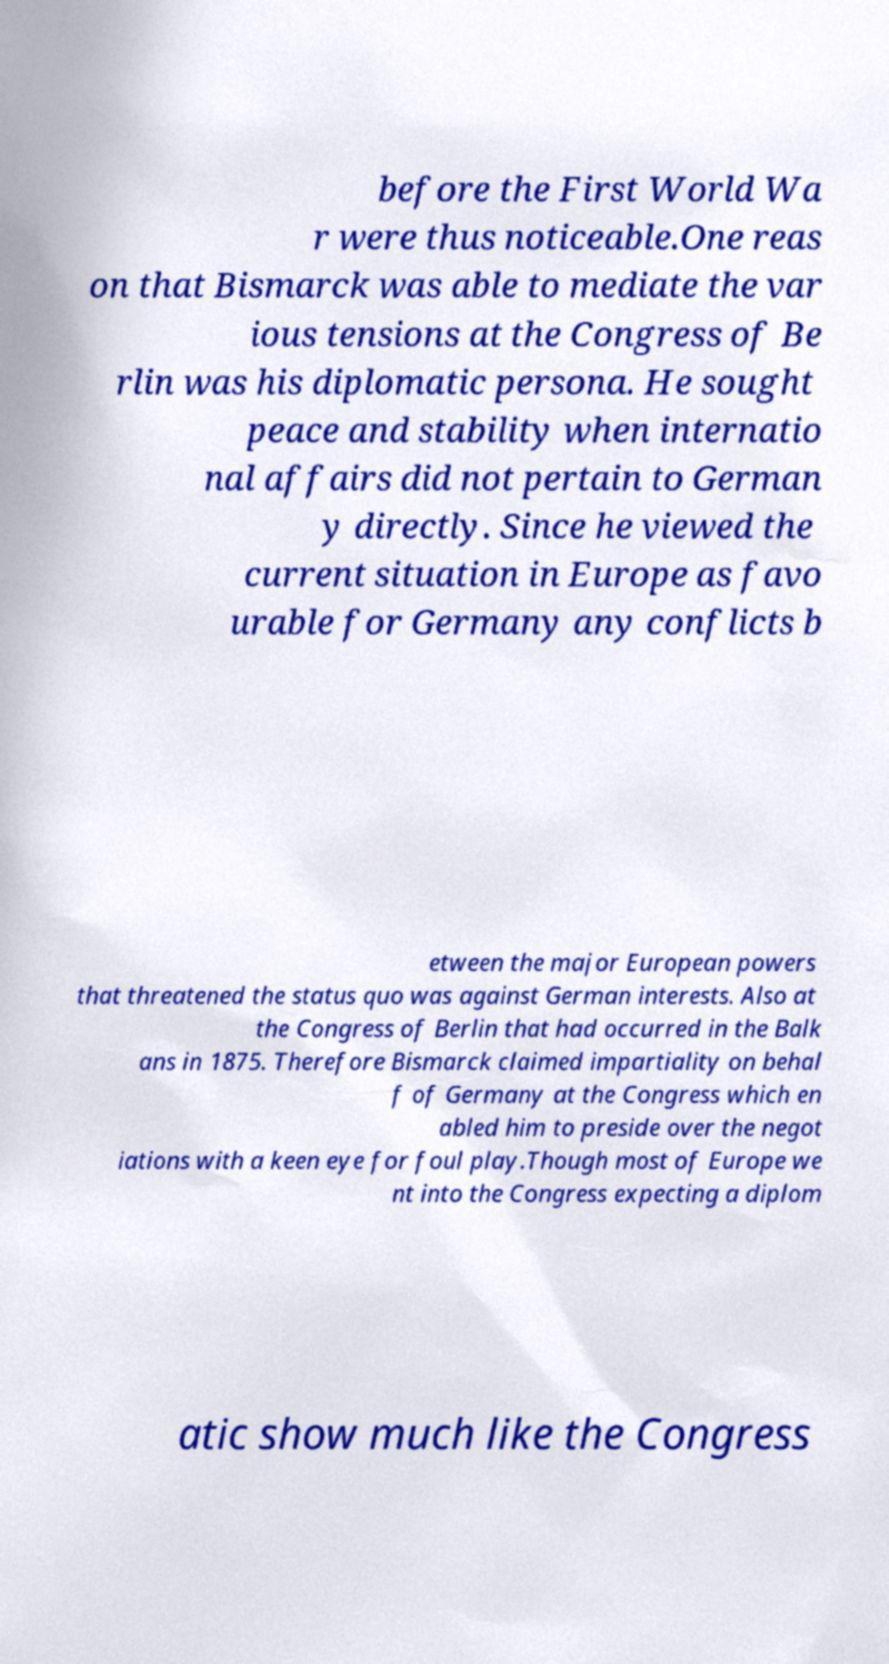Please read and relay the text visible in this image. What does it say? before the First World Wa r were thus noticeable.One reas on that Bismarck was able to mediate the var ious tensions at the Congress of Be rlin was his diplomatic persona. He sought peace and stability when internatio nal affairs did not pertain to German y directly. Since he viewed the current situation in Europe as favo urable for Germany any conflicts b etween the major European powers that threatened the status quo was against German interests. Also at the Congress of Berlin that had occurred in the Balk ans in 1875. Therefore Bismarck claimed impartiality on behal f of Germany at the Congress which en abled him to preside over the negot iations with a keen eye for foul play.Though most of Europe we nt into the Congress expecting a diplom atic show much like the Congress 